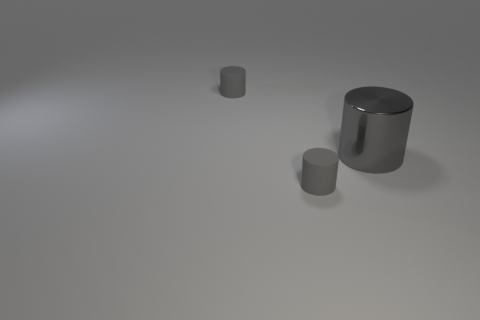Are there any gray cylinders to the right of the big metal cylinder?
Make the answer very short. No. Is there another yellow shiny object that has the same shape as the big thing?
Give a very brief answer. No. What number of things are either gray cylinders that are in front of the big metal cylinder or small gray matte things?
Give a very brief answer. 2. There is a gray object that is behind the gray metallic cylinder; how big is it?
Offer a very short reply. Small. Is there a cyan rubber sphere of the same size as the metal thing?
Offer a terse response. No. There is a rubber object that is in front of the gray metal thing; does it have the same size as the large gray metallic cylinder?
Ensure brevity in your answer.  No. The gray shiny cylinder is what size?
Offer a very short reply. Large. There is a object that is in front of the gray metal object; is its color the same as the big cylinder?
Provide a succinct answer. Yes. How many gray rubber cylinders are behind the big gray metal cylinder and in front of the large gray thing?
Your answer should be very brief. 0. How many gray cylinders are on the left side of the tiny gray cylinder to the right of the cylinder that is behind the shiny object?
Offer a terse response. 1. 